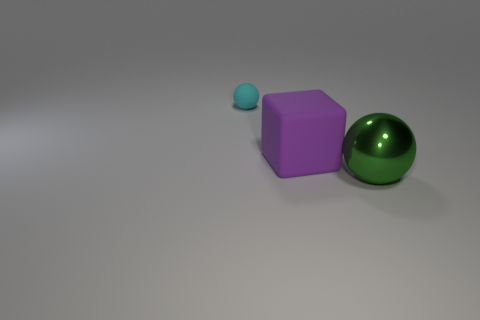Is the number of rubber things behind the big purple rubber object less than the number of balls?
Provide a succinct answer. Yes. Are the big block and the sphere that is left of the green metallic object made of the same material?
Provide a short and direct response. Yes. There is a big object in front of the large thing that is behind the green metallic thing; is there a rubber thing that is in front of it?
Keep it short and to the point. No. Are there any other things that have the same size as the cyan rubber sphere?
Your answer should be compact. No. There is a small object that is made of the same material as the block; what is its color?
Give a very brief answer. Cyan. Are there fewer large shiny objects that are behind the green sphere than green metal objects that are on the right side of the large purple cube?
Make the answer very short. Yes. Are the tiny cyan object left of the large purple matte object and the ball that is in front of the cyan sphere made of the same material?
Your answer should be very brief. No. What shape is the thing that is behind the green ball and in front of the cyan rubber ball?
Keep it short and to the point. Cube. There is a ball that is in front of the thing that is behind the purple matte thing; what is it made of?
Provide a succinct answer. Metal. Is the number of tiny objects greater than the number of tiny yellow metallic cylinders?
Your response must be concise. Yes. 